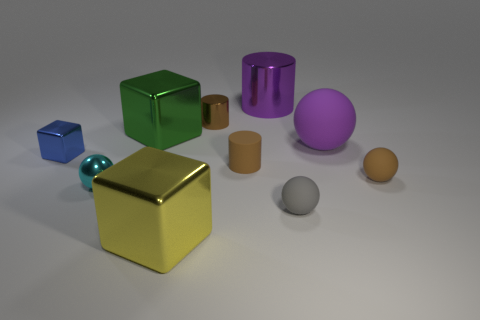There is a sphere that is the same color as the rubber cylinder; what material is it?
Your answer should be very brief. Rubber. Is the number of tiny cylinders that are behind the purple cylinder less than the number of tiny brown cubes?
Provide a succinct answer. No. Are there any other tiny shiny cubes that have the same color as the tiny metal block?
Give a very brief answer. No. Does the small cyan metal object have the same shape as the blue object that is in front of the tiny metallic cylinder?
Ensure brevity in your answer.  No. Are there any green things made of the same material as the big yellow cube?
Your answer should be compact. Yes. There is a tiny matte object that is in front of the tiny matte sphere that is behind the small gray matte thing; are there any yellow cubes behind it?
Offer a very short reply. No. What number of other things are the same shape as the big yellow metallic thing?
Ensure brevity in your answer.  2. The ball that is to the left of the gray matte ball that is in front of the small brown object to the right of the large purple sphere is what color?
Give a very brief answer. Cyan. What number of tiny matte spheres are there?
Make the answer very short. 2. How many tiny objects are either purple things or cyan objects?
Provide a short and direct response. 1. 